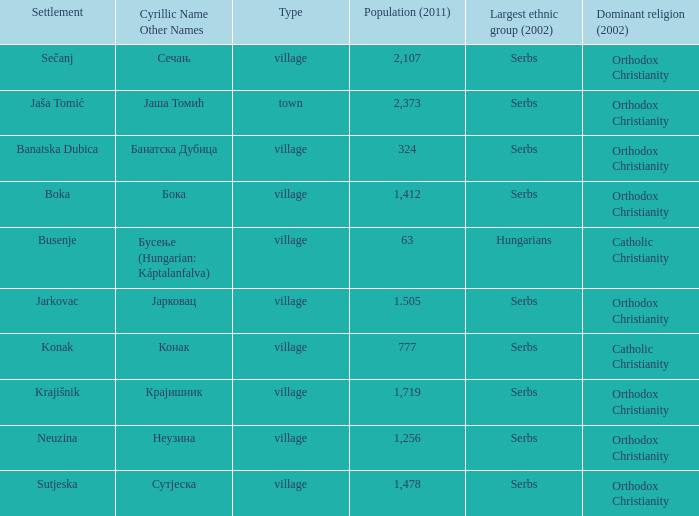What is the ethnic community related to конак? Serbs. 